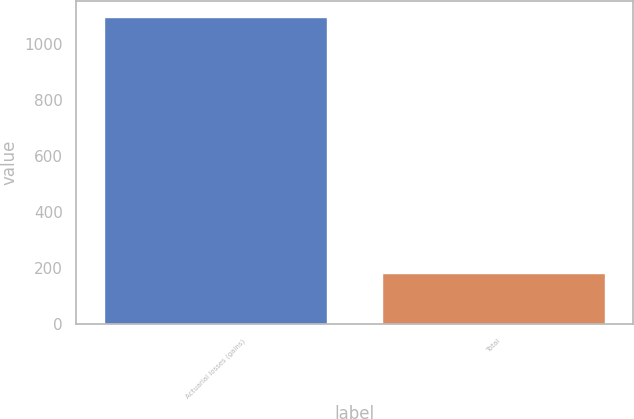Convert chart to OTSL. <chart><loc_0><loc_0><loc_500><loc_500><bar_chart><fcel>Actuarial losses (gains)<fcel>Total<nl><fcel>1097<fcel>184<nl></chart> 